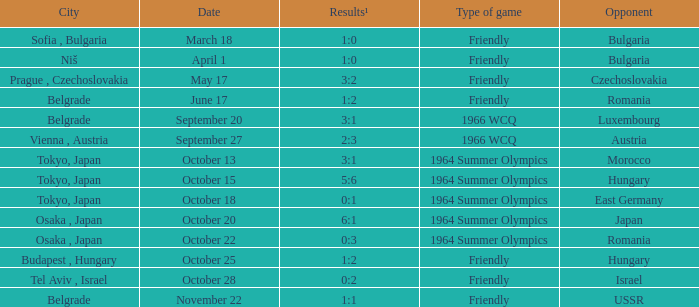What day were the results 3:2? May 17. 